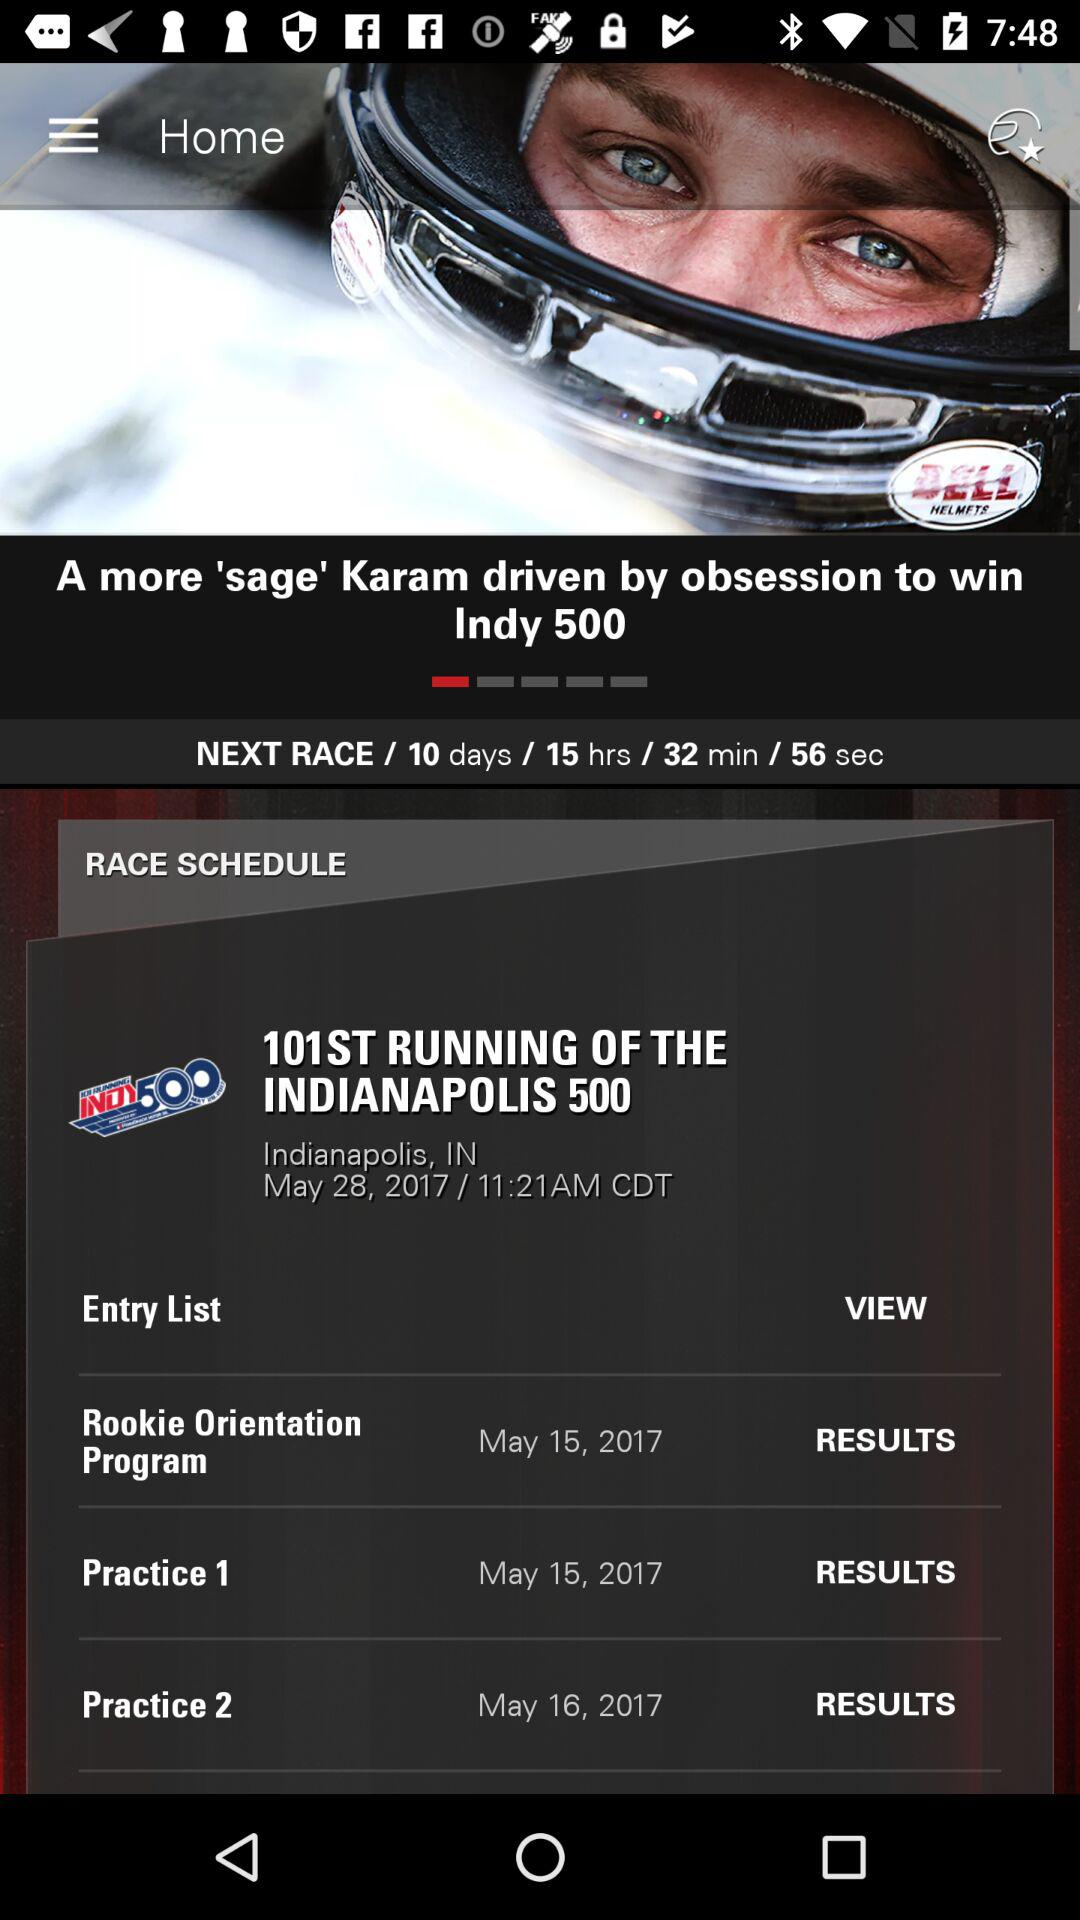On what date did Practice 2 happen? The date is May 16, 2017. 